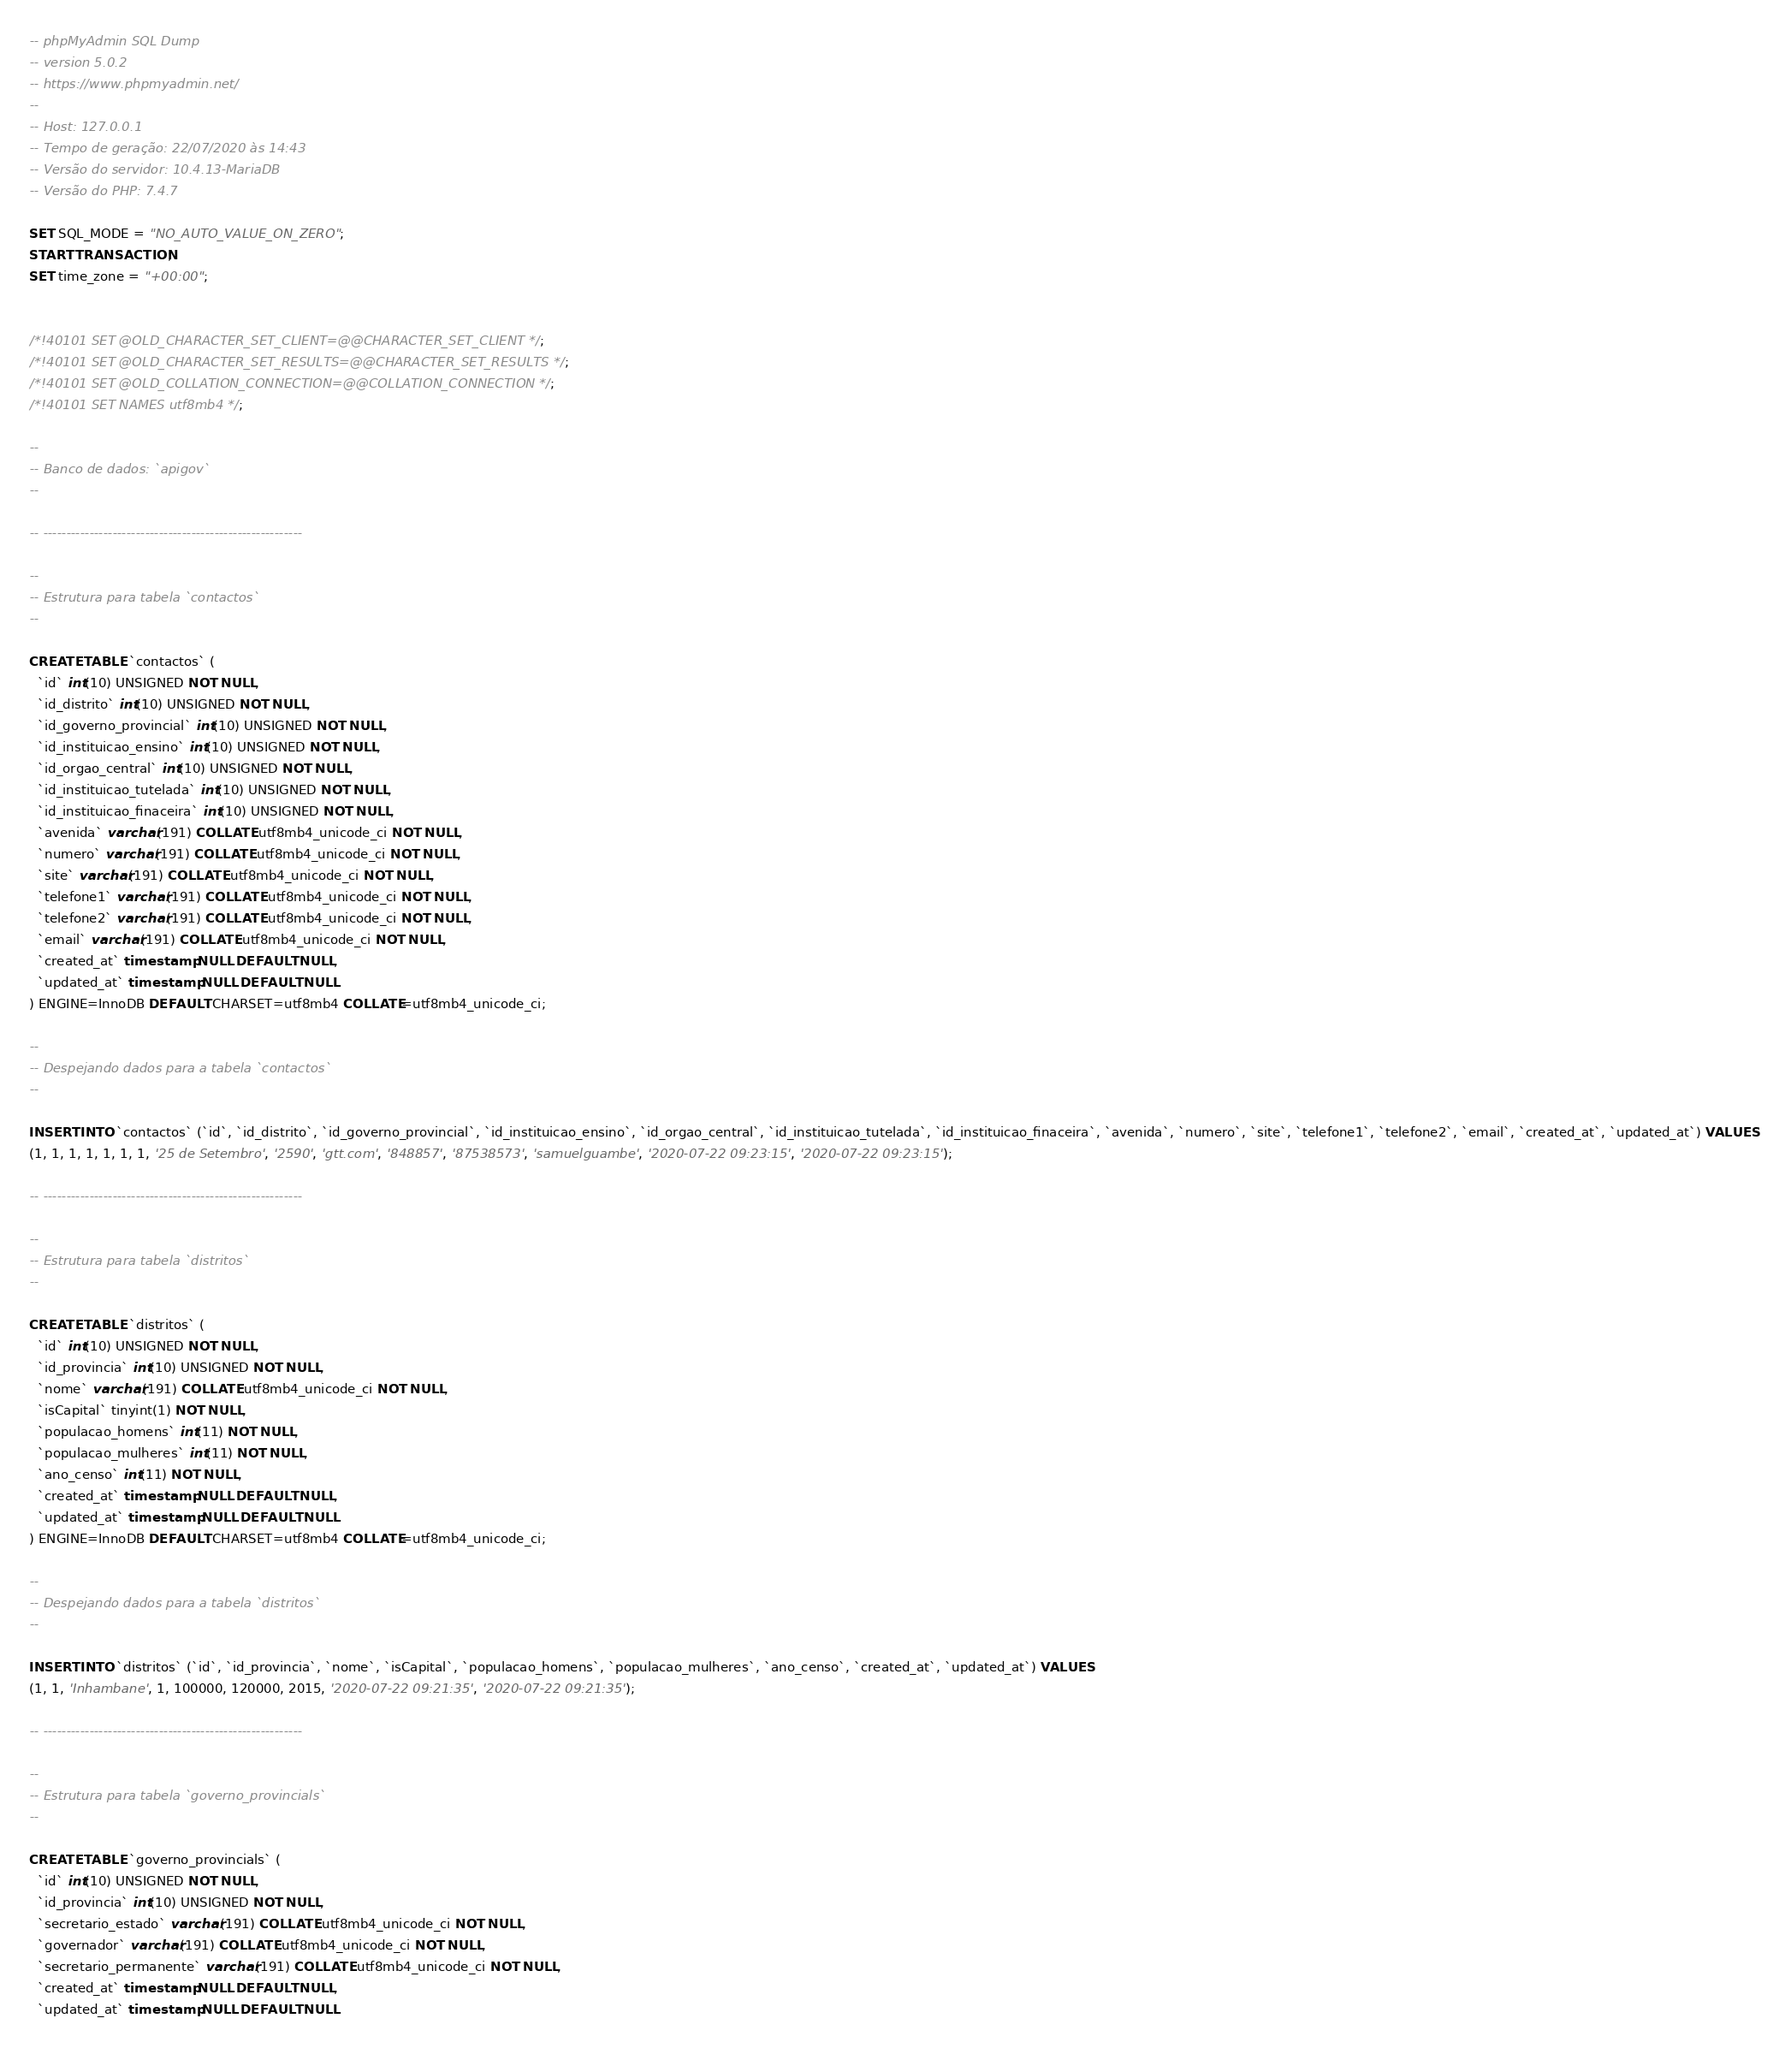<code> <loc_0><loc_0><loc_500><loc_500><_SQL_>-- phpMyAdmin SQL Dump
-- version 5.0.2
-- https://www.phpmyadmin.net/
--
-- Host: 127.0.0.1
-- Tempo de geração: 22/07/2020 às 14:43
-- Versão do servidor: 10.4.13-MariaDB
-- Versão do PHP: 7.4.7

SET SQL_MODE = "NO_AUTO_VALUE_ON_ZERO";
START TRANSACTION;
SET time_zone = "+00:00";


/*!40101 SET @OLD_CHARACTER_SET_CLIENT=@@CHARACTER_SET_CLIENT */;
/*!40101 SET @OLD_CHARACTER_SET_RESULTS=@@CHARACTER_SET_RESULTS */;
/*!40101 SET @OLD_COLLATION_CONNECTION=@@COLLATION_CONNECTION */;
/*!40101 SET NAMES utf8mb4 */;

--
-- Banco de dados: `apigov`
--

-- --------------------------------------------------------

--
-- Estrutura para tabela `contactos`
--

CREATE TABLE `contactos` (
  `id` int(10) UNSIGNED NOT NULL,
  `id_distrito` int(10) UNSIGNED NOT NULL,
  `id_governo_provincial` int(10) UNSIGNED NOT NULL,
  `id_instituicao_ensino` int(10) UNSIGNED NOT NULL,
  `id_orgao_central` int(10) UNSIGNED NOT NULL,
  `id_instituicao_tutelada` int(10) UNSIGNED NOT NULL,
  `id_instituicao_finaceira` int(10) UNSIGNED NOT NULL,
  `avenida` varchar(191) COLLATE utf8mb4_unicode_ci NOT NULL,
  `numero` varchar(191) COLLATE utf8mb4_unicode_ci NOT NULL,
  `site` varchar(191) COLLATE utf8mb4_unicode_ci NOT NULL,
  `telefone1` varchar(191) COLLATE utf8mb4_unicode_ci NOT NULL,
  `telefone2` varchar(191) COLLATE utf8mb4_unicode_ci NOT NULL,
  `email` varchar(191) COLLATE utf8mb4_unicode_ci NOT NULL,
  `created_at` timestamp NULL DEFAULT NULL,
  `updated_at` timestamp NULL DEFAULT NULL
) ENGINE=InnoDB DEFAULT CHARSET=utf8mb4 COLLATE=utf8mb4_unicode_ci;

--
-- Despejando dados para a tabela `contactos`
--

INSERT INTO `contactos` (`id`, `id_distrito`, `id_governo_provincial`, `id_instituicao_ensino`, `id_orgao_central`, `id_instituicao_tutelada`, `id_instituicao_finaceira`, `avenida`, `numero`, `site`, `telefone1`, `telefone2`, `email`, `created_at`, `updated_at`) VALUES
(1, 1, 1, 1, 1, 1, 1, '25 de Setembro', '2590', 'gtt.com', '848857', '87538573', 'samuelguambe', '2020-07-22 09:23:15', '2020-07-22 09:23:15');

-- --------------------------------------------------------

--
-- Estrutura para tabela `distritos`
--

CREATE TABLE `distritos` (
  `id` int(10) UNSIGNED NOT NULL,
  `id_provincia` int(10) UNSIGNED NOT NULL,
  `nome` varchar(191) COLLATE utf8mb4_unicode_ci NOT NULL,
  `isCapital` tinyint(1) NOT NULL,
  `populacao_homens` int(11) NOT NULL,
  `populacao_mulheres` int(11) NOT NULL,
  `ano_censo` int(11) NOT NULL,
  `created_at` timestamp NULL DEFAULT NULL,
  `updated_at` timestamp NULL DEFAULT NULL
) ENGINE=InnoDB DEFAULT CHARSET=utf8mb4 COLLATE=utf8mb4_unicode_ci;

--
-- Despejando dados para a tabela `distritos`
--

INSERT INTO `distritos` (`id`, `id_provincia`, `nome`, `isCapital`, `populacao_homens`, `populacao_mulheres`, `ano_censo`, `created_at`, `updated_at`) VALUES
(1, 1, 'Inhambane', 1, 100000, 120000, 2015, '2020-07-22 09:21:35', '2020-07-22 09:21:35');

-- --------------------------------------------------------

--
-- Estrutura para tabela `governo_provincials`
--

CREATE TABLE `governo_provincials` (
  `id` int(10) UNSIGNED NOT NULL,
  `id_provincia` int(10) UNSIGNED NOT NULL,
  `secretario_estado` varchar(191) COLLATE utf8mb4_unicode_ci NOT NULL,
  `governador` varchar(191) COLLATE utf8mb4_unicode_ci NOT NULL,
  `secretario_permanente` varchar(191) COLLATE utf8mb4_unicode_ci NOT NULL,
  `created_at` timestamp NULL DEFAULT NULL,
  `updated_at` timestamp NULL DEFAULT NULL</code> 